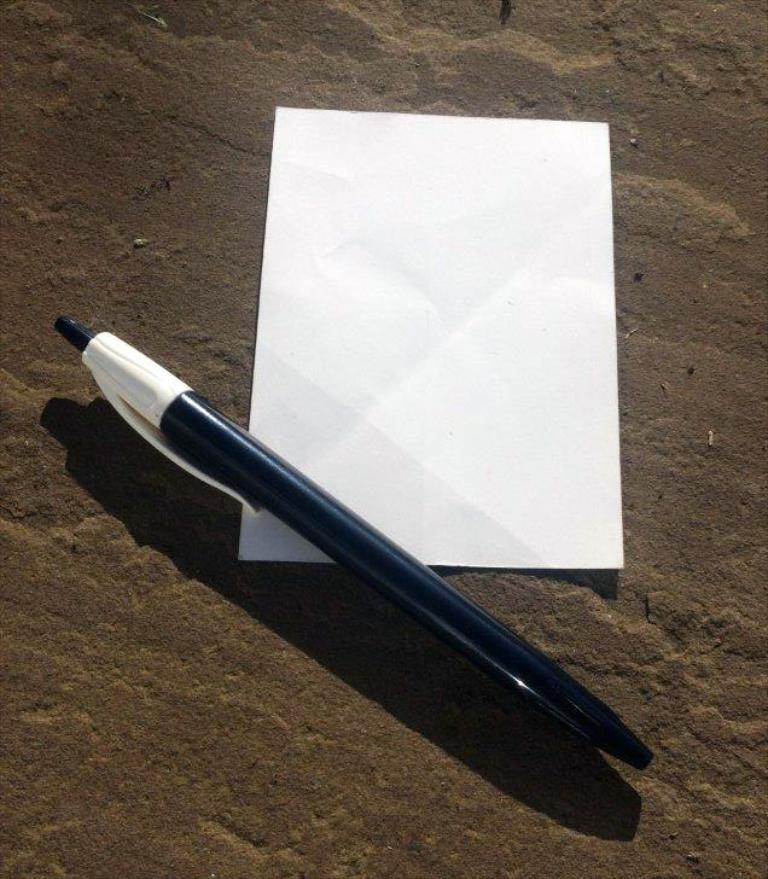What is present on the land in the image? There is a paper placed on the land in the image. What is the color of the pen in the image? The pen in the image is black. Where is the pen located in relation to the paper? The pen is placed on the paper. What type of furniture can be seen in the image? There is no furniture present in the image. Is there a volcano visible in the image? No, there is no volcano in the image. 